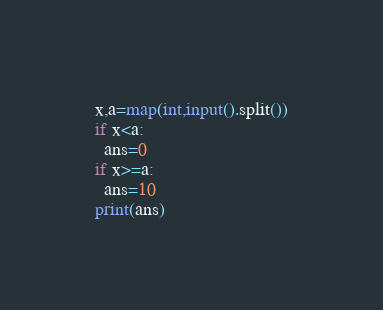<code> <loc_0><loc_0><loc_500><loc_500><_Python_>x,a=map(int,input().split())
if x<a:
  ans=0
if x>=a:
  ans=10
print(ans)</code> 